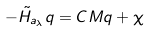Convert formula to latex. <formula><loc_0><loc_0><loc_500><loc_500>- \tilde { H } _ { a _ { \lambda } } q = C M q + \chi</formula> 